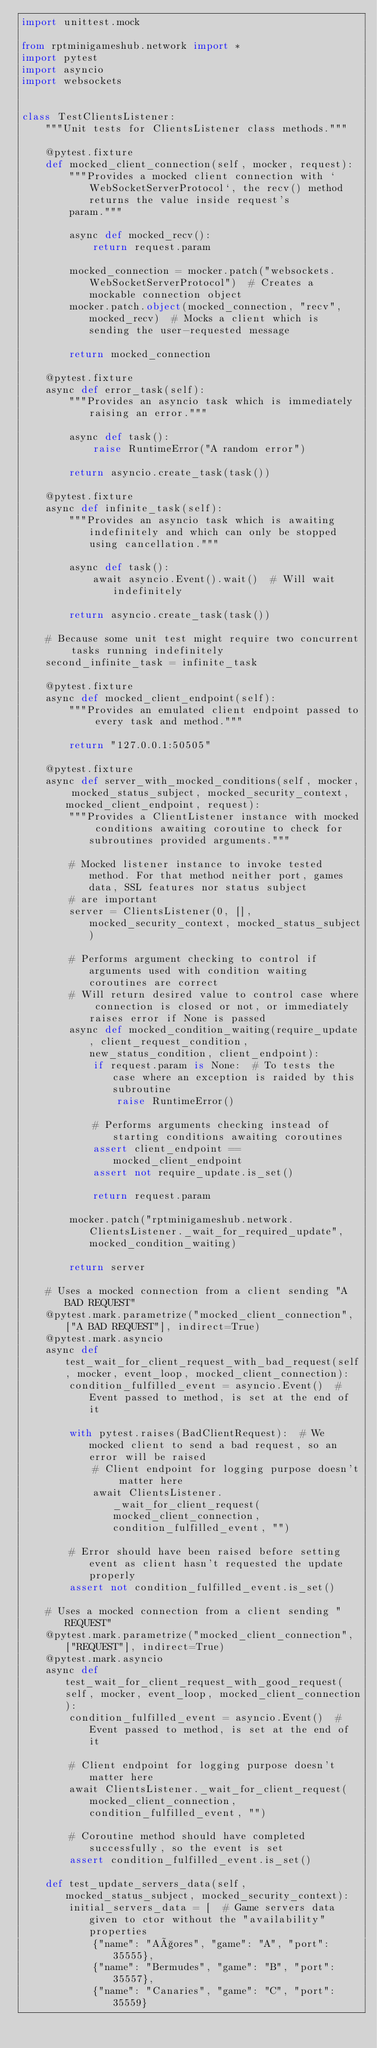<code> <loc_0><loc_0><loc_500><loc_500><_Python_>import unittest.mock

from rptminigameshub.network import *
import pytest
import asyncio
import websockets


class TestClientsListener:
    """Unit tests for ClientsListener class methods."""

    @pytest.fixture
    def mocked_client_connection(self, mocker, request):
        """Provides a mocked client connection with `WebSocketServerProtocol`, the recv() method returns the value inside request's
        param."""

        async def mocked_recv():
            return request.param

        mocked_connection = mocker.patch("websockets.WebSocketServerProtocol")  # Creates a mockable connection object
        mocker.patch.object(mocked_connection, "recv", mocked_recv)  # Mocks a client which is sending the user-requested message

        return mocked_connection

    @pytest.fixture
    async def error_task(self):
        """Provides an asyncio task which is immediately raising an error."""

        async def task():
            raise RuntimeError("A random error")

        return asyncio.create_task(task())

    @pytest.fixture
    async def infinite_task(self):
        """Provides an asyncio task which is awaiting indefinitely and which can only be stopped using cancellation."""

        async def task():
            await asyncio.Event().wait()  # Will wait indefinitely

        return asyncio.create_task(task())

    # Because some unit test might require two concurrent tasks running indefinitely
    second_infinite_task = infinite_task

    @pytest.fixture
    async def mocked_client_endpoint(self):
        """Provides an emulated client endpoint passed to every task and method."""

        return "127.0.0.1:50505"

    @pytest.fixture
    async def server_with_mocked_conditions(self, mocker, mocked_status_subject, mocked_security_context, mocked_client_endpoint, request):
        """Provides a ClientListener instance with mocked conditions awaiting coroutine to check for subroutines provided arguments."""

        # Mocked listener instance to invoke tested method. For that method neither port, games data, SSL features nor status subject
        # are important
        server = ClientsListener(0, [], mocked_security_context, mocked_status_subject)

        # Performs argument checking to control if arguments used with condition waiting coroutines are correct
        # Will return desired value to control case where connection is closed or not, or immediately raises error if None is passed
        async def mocked_condition_waiting(require_update, client_request_condition, new_status_condition, client_endpoint):
            if request.param is None:  # To tests the case where an exception is raided by this subroutine
                raise RuntimeError()

            # Performs arguments checking instead of starting conditions awaiting coroutines
            assert client_endpoint == mocked_client_endpoint
            assert not require_update.is_set()

            return request.param

        mocker.patch("rptminigameshub.network.ClientsListener._wait_for_required_update", mocked_condition_waiting)

        return server

    # Uses a mocked connection from a client sending "A BAD REQUEST"
    @pytest.mark.parametrize("mocked_client_connection", ["A BAD REQUEST"], indirect=True)
    @pytest.mark.asyncio
    async def test_wait_for_client_request_with_bad_request(self, mocker, event_loop, mocked_client_connection):
        condition_fulfilled_event = asyncio.Event()  # Event passed to method, is set at the end of it

        with pytest.raises(BadClientRequest):  # We mocked client to send a bad request, so an error will be raised
            # Client endpoint for logging purpose doesn't matter here
            await ClientsListener._wait_for_client_request(mocked_client_connection, condition_fulfilled_event, "")

        # Error should have been raised before setting event as client hasn't requested the update properly
        assert not condition_fulfilled_event.is_set()

    # Uses a mocked connection from a client sending "REQUEST"
    @pytest.mark.parametrize("mocked_client_connection", ["REQUEST"], indirect=True)
    @pytest.mark.asyncio
    async def test_wait_for_client_request_with_good_request(self, mocker, event_loop, mocked_client_connection):
        condition_fulfilled_event = asyncio.Event()  # Event passed to method, is set at the end of it

        # Client endpoint for logging purpose doesn't matter here
        await ClientsListener._wait_for_client_request(mocked_client_connection, condition_fulfilled_event, "")

        # Coroutine method should have completed successfully, so the event is set
        assert condition_fulfilled_event.is_set()

    def test_update_servers_data(self, mocked_status_subject, mocked_security_context):
        initial_servers_data = [  # Game servers data given to ctor without the "availability" properties
            {"name": "Açores", "game": "A", "port": 35555},
            {"name": "Bermudes", "game": "B", "port": 35557},
            {"name": "Canaries", "game": "C", "port": 35559}</code> 